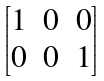<formula> <loc_0><loc_0><loc_500><loc_500>\begin{bmatrix} 1 & 0 & 0 \\ 0 & 0 & 1 \\ \end{bmatrix}</formula> 